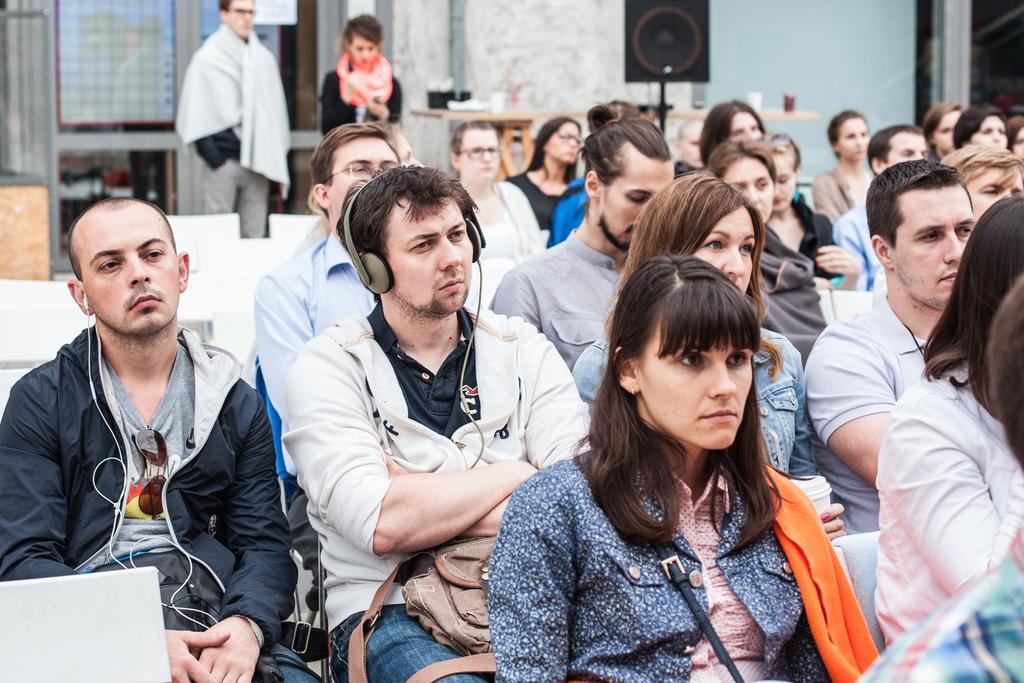Describe this image in one or two sentences. In this image in front there are people sitting on the chairs. Behind them there are two other people standing. On the left side of the image there is a laptop. In the background of the image there is a wall. In front of the wall there are two tables. On top of it there are some objects. There is a blackboard. 